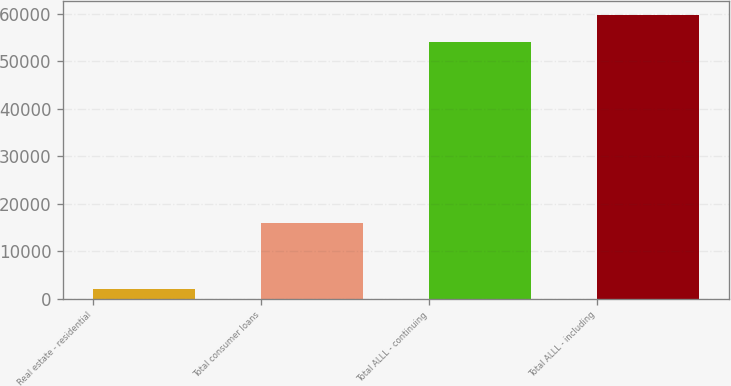Convert chart to OTSL. <chart><loc_0><loc_0><loc_500><loc_500><bar_chart><fcel>Real estate - residential<fcel>Total consumer loans<fcel>Total ALLL - continuing<fcel>Total ALLL - including<nl><fcel>2117<fcel>15884<fcel>54083<fcel>59728<nl></chart> 